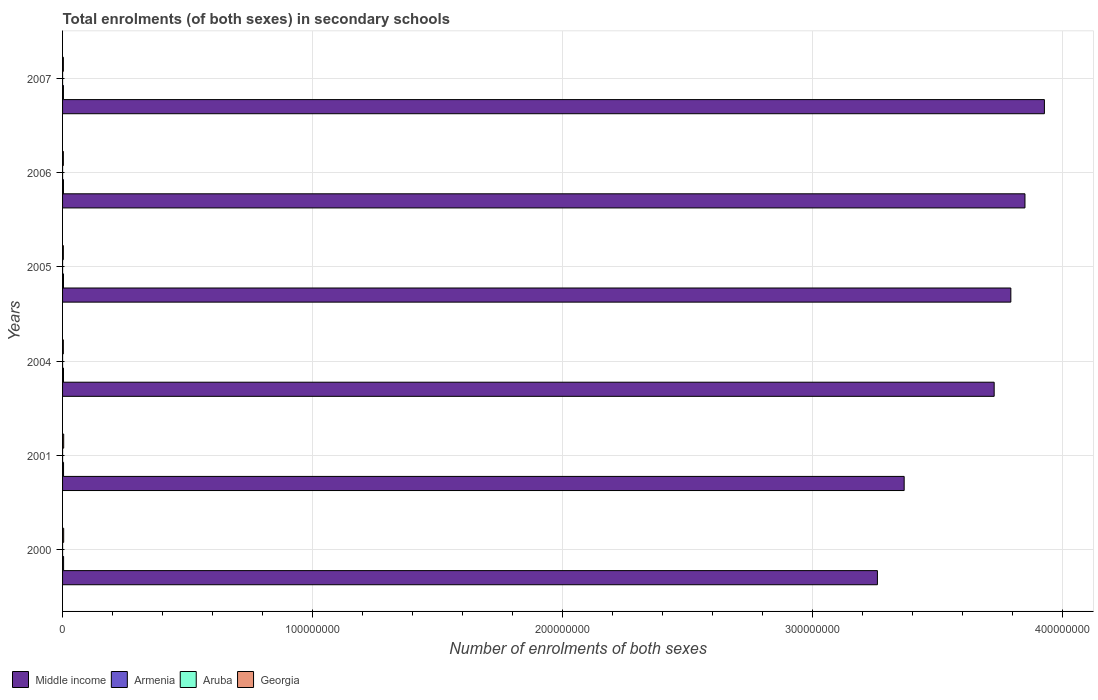Are the number of bars per tick equal to the number of legend labels?
Make the answer very short. Yes. Are the number of bars on each tick of the Y-axis equal?
Keep it short and to the point. Yes. How many bars are there on the 6th tick from the top?
Your answer should be compact. 4. In how many cases, is the number of bars for a given year not equal to the number of legend labels?
Your answer should be compact. 0. What is the number of enrolments in secondary schools in Middle income in 2005?
Give a very brief answer. 3.79e+08. Across all years, what is the maximum number of enrolments in secondary schools in Georgia?
Your answer should be very brief. 4.49e+05. Across all years, what is the minimum number of enrolments in secondary schools in Georgia?
Your answer should be compact. 3.12e+05. What is the total number of enrolments in secondary schools in Aruba in the graph?
Keep it short and to the point. 4.20e+04. What is the difference between the number of enrolments in secondary schools in Georgia in 2006 and that in 2007?
Give a very brief answer. -6744. What is the difference between the number of enrolments in secondary schools in Armenia in 2000 and the number of enrolments in secondary schools in Middle income in 2007?
Make the answer very short. -3.92e+08. What is the average number of enrolments in secondary schools in Aruba per year?
Keep it short and to the point. 6997.83. In the year 2000, what is the difference between the number of enrolments in secondary schools in Armenia and number of enrolments in secondary schools in Georgia?
Keep it short and to the point. -3.42e+04. What is the ratio of the number of enrolments in secondary schools in Armenia in 2000 to that in 2005?
Your answer should be very brief. 1.11. What is the difference between the highest and the second highest number of enrolments in secondary schools in Armenia?
Make the answer very short. 1.60e+04. What is the difference between the highest and the lowest number of enrolments in secondary schools in Armenia?
Offer a very short reply. 6.36e+04. Is it the case that in every year, the sum of the number of enrolments in secondary schools in Middle income and number of enrolments in secondary schools in Aruba is greater than the sum of number of enrolments in secondary schools in Armenia and number of enrolments in secondary schools in Georgia?
Offer a very short reply. Yes. What does the 3rd bar from the top in 2005 represents?
Provide a short and direct response. Armenia. What does the 1st bar from the bottom in 2004 represents?
Your answer should be very brief. Middle income. Is it the case that in every year, the sum of the number of enrolments in secondary schools in Armenia and number of enrolments in secondary schools in Georgia is greater than the number of enrolments in secondary schools in Aruba?
Provide a succinct answer. Yes. Are the values on the major ticks of X-axis written in scientific E-notation?
Offer a terse response. No. Does the graph contain grids?
Your response must be concise. Yes. Where does the legend appear in the graph?
Offer a terse response. Bottom left. How are the legend labels stacked?
Ensure brevity in your answer.  Horizontal. What is the title of the graph?
Keep it short and to the point. Total enrolments (of both sexes) in secondary schools. What is the label or title of the X-axis?
Give a very brief answer. Number of enrolments of both sexes. What is the Number of enrolments of both sexes of Middle income in 2000?
Ensure brevity in your answer.  3.26e+08. What is the Number of enrolments of both sexes in Armenia in 2000?
Offer a terse response. 4.09e+05. What is the Number of enrolments of both sexes of Aruba in 2000?
Offer a very short reply. 6178. What is the Number of enrolments of both sexes in Georgia in 2000?
Make the answer very short. 4.44e+05. What is the Number of enrolments of both sexes of Middle income in 2001?
Your answer should be very brief. 3.37e+08. What is the Number of enrolments of both sexes in Armenia in 2001?
Offer a terse response. 3.93e+05. What is the Number of enrolments of both sexes in Aruba in 2001?
Your answer should be very brief. 6428. What is the Number of enrolments of both sexes of Georgia in 2001?
Offer a very short reply. 4.49e+05. What is the Number of enrolments of both sexes of Middle income in 2004?
Ensure brevity in your answer.  3.73e+08. What is the Number of enrolments of both sexes in Armenia in 2004?
Your response must be concise. 3.74e+05. What is the Number of enrolments of both sexes of Aruba in 2004?
Keep it short and to the point. 6973. What is the Number of enrolments of both sexes in Georgia in 2004?
Give a very brief answer. 3.12e+05. What is the Number of enrolments of both sexes of Middle income in 2005?
Give a very brief answer. 3.79e+08. What is the Number of enrolments of both sexes of Armenia in 2005?
Give a very brief answer. 3.70e+05. What is the Number of enrolments of both sexes in Aruba in 2005?
Your response must be concise. 7116. What is the Number of enrolments of both sexes of Georgia in 2005?
Ensure brevity in your answer.  3.16e+05. What is the Number of enrolments of both sexes in Middle income in 2006?
Make the answer very short. 3.85e+08. What is the Number of enrolments of both sexes in Armenia in 2006?
Provide a succinct answer. 3.63e+05. What is the Number of enrolments of both sexes in Aruba in 2006?
Keep it short and to the point. 7439. What is the Number of enrolments of both sexes in Georgia in 2006?
Provide a succinct answer. 3.14e+05. What is the Number of enrolments of both sexes in Middle income in 2007?
Give a very brief answer. 3.93e+08. What is the Number of enrolments of both sexes of Armenia in 2007?
Ensure brevity in your answer.  3.46e+05. What is the Number of enrolments of both sexes of Aruba in 2007?
Give a very brief answer. 7853. What is the Number of enrolments of both sexes in Georgia in 2007?
Your answer should be very brief. 3.21e+05. Across all years, what is the maximum Number of enrolments of both sexes in Middle income?
Provide a short and direct response. 3.93e+08. Across all years, what is the maximum Number of enrolments of both sexes of Armenia?
Offer a terse response. 4.09e+05. Across all years, what is the maximum Number of enrolments of both sexes in Aruba?
Make the answer very short. 7853. Across all years, what is the maximum Number of enrolments of both sexes of Georgia?
Give a very brief answer. 4.49e+05. Across all years, what is the minimum Number of enrolments of both sexes of Middle income?
Provide a succinct answer. 3.26e+08. Across all years, what is the minimum Number of enrolments of both sexes in Armenia?
Give a very brief answer. 3.46e+05. Across all years, what is the minimum Number of enrolments of both sexes in Aruba?
Offer a terse response. 6178. Across all years, what is the minimum Number of enrolments of both sexes in Georgia?
Give a very brief answer. 3.12e+05. What is the total Number of enrolments of both sexes of Middle income in the graph?
Your answer should be very brief. 2.19e+09. What is the total Number of enrolments of both sexes in Armenia in the graph?
Make the answer very short. 2.25e+06. What is the total Number of enrolments of both sexes in Aruba in the graph?
Provide a succinct answer. 4.20e+04. What is the total Number of enrolments of both sexes in Georgia in the graph?
Keep it short and to the point. 2.16e+06. What is the difference between the Number of enrolments of both sexes of Middle income in 2000 and that in 2001?
Keep it short and to the point. -1.07e+07. What is the difference between the Number of enrolments of both sexes of Armenia in 2000 and that in 2001?
Give a very brief answer. 1.60e+04. What is the difference between the Number of enrolments of both sexes of Aruba in 2000 and that in 2001?
Make the answer very short. -250. What is the difference between the Number of enrolments of both sexes in Georgia in 2000 and that in 2001?
Make the answer very short. -4921. What is the difference between the Number of enrolments of both sexes in Middle income in 2000 and that in 2004?
Your answer should be very brief. -4.67e+07. What is the difference between the Number of enrolments of both sexes of Armenia in 2000 and that in 2004?
Provide a short and direct response. 3.57e+04. What is the difference between the Number of enrolments of both sexes of Aruba in 2000 and that in 2004?
Your response must be concise. -795. What is the difference between the Number of enrolments of both sexes in Georgia in 2000 and that in 2004?
Give a very brief answer. 1.31e+05. What is the difference between the Number of enrolments of both sexes of Middle income in 2000 and that in 2005?
Your answer should be very brief. -5.34e+07. What is the difference between the Number of enrolments of both sexes in Armenia in 2000 and that in 2005?
Your answer should be very brief. 3.97e+04. What is the difference between the Number of enrolments of both sexes in Aruba in 2000 and that in 2005?
Make the answer very short. -938. What is the difference between the Number of enrolments of both sexes of Georgia in 2000 and that in 2005?
Your answer should be very brief. 1.27e+05. What is the difference between the Number of enrolments of both sexes in Middle income in 2000 and that in 2006?
Offer a terse response. -5.90e+07. What is the difference between the Number of enrolments of both sexes of Armenia in 2000 and that in 2006?
Keep it short and to the point. 4.69e+04. What is the difference between the Number of enrolments of both sexes of Aruba in 2000 and that in 2006?
Provide a short and direct response. -1261. What is the difference between the Number of enrolments of both sexes in Georgia in 2000 and that in 2006?
Your response must be concise. 1.29e+05. What is the difference between the Number of enrolments of both sexes of Middle income in 2000 and that in 2007?
Give a very brief answer. -6.68e+07. What is the difference between the Number of enrolments of both sexes in Armenia in 2000 and that in 2007?
Ensure brevity in your answer.  6.36e+04. What is the difference between the Number of enrolments of both sexes of Aruba in 2000 and that in 2007?
Make the answer very short. -1675. What is the difference between the Number of enrolments of both sexes of Georgia in 2000 and that in 2007?
Your answer should be compact. 1.22e+05. What is the difference between the Number of enrolments of both sexes in Middle income in 2001 and that in 2004?
Offer a terse response. -3.60e+07. What is the difference between the Number of enrolments of both sexes in Armenia in 2001 and that in 2004?
Make the answer very short. 1.97e+04. What is the difference between the Number of enrolments of both sexes of Aruba in 2001 and that in 2004?
Offer a very short reply. -545. What is the difference between the Number of enrolments of both sexes in Georgia in 2001 and that in 2004?
Offer a very short reply. 1.36e+05. What is the difference between the Number of enrolments of both sexes of Middle income in 2001 and that in 2005?
Offer a very short reply. -4.27e+07. What is the difference between the Number of enrolments of both sexes of Armenia in 2001 and that in 2005?
Offer a terse response. 2.37e+04. What is the difference between the Number of enrolments of both sexes in Aruba in 2001 and that in 2005?
Give a very brief answer. -688. What is the difference between the Number of enrolments of both sexes in Georgia in 2001 and that in 2005?
Ensure brevity in your answer.  1.32e+05. What is the difference between the Number of enrolments of both sexes in Middle income in 2001 and that in 2006?
Provide a short and direct response. -4.83e+07. What is the difference between the Number of enrolments of both sexes in Armenia in 2001 and that in 2006?
Provide a succinct answer. 3.09e+04. What is the difference between the Number of enrolments of both sexes of Aruba in 2001 and that in 2006?
Offer a terse response. -1011. What is the difference between the Number of enrolments of both sexes in Georgia in 2001 and that in 2006?
Keep it short and to the point. 1.34e+05. What is the difference between the Number of enrolments of both sexes in Middle income in 2001 and that in 2007?
Your answer should be very brief. -5.61e+07. What is the difference between the Number of enrolments of both sexes in Armenia in 2001 and that in 2007?
Ensure brevity in your answer.  4.76e+04. What is the difference between the Number of enrolments of both sexes in Aruba in 2001 and that in 2007?
Make the answer very short. -1425. What is the difference between the Number of enrolments of both sexes in Georgia in 2001 and that in 2007?
Offer a terse response. 1.27e+05. What is the difference between the Number of enrolments of both sexes in Middle income in 2004 and that in 2005?
Your response must be concise. -6.67e+06. What is the difference between the Number of enrolments of both sexes of Armenia in 2004 and that in 2005?
Your answer should be very brief. 3957. What is the difference between the Number of enrolments of both sexes in Aruba in 2004 and that in 2005?
Give a very brief answer. -143. What is the difference between the Number of enrolments of both sexes of Georgia in 2004 and that in 2005?
Give a very brief answer. -4097. What is the difference between the Number of enrolments of both sexes of Middle income in 2004 and that in 2006?
Your response must be concise. -1.23e+07. What is the difference between the Number of enrolments of both sexes of Armenia in 2004 and that in 2006?
Your answer should be very brief. 1.12e+04. What is the difference between the Number of enrolments of both sexes of Aruba in 2004 and that in 2006?
Provide a succinct answer. -466. What is the difference between the Number of enrolments of both sexes of Georgia in 2004 and that in 2006?
Offer a terse response. -2094. What is the difference between the Number of enrolments of both sexes in Middle income in 2004 and that in 2007?
Provide a succinct answer. -2.01e+07. What is the difference between the Number of enrolments of both sexes in Armenia in 2004 and that in 2007?
Provide a succinct answer. 2.79e+04. What is the difference between the Number of enrolments of both sexes in Aruba in 2004 and that in 2007?
Your answer should be compact. -880. What is the difference between the Number of enrolments of both sexes in Georgia in 2004 and that in 2007?
Provide a short and direct response. -8838. What is the difference between the Number of enrolments of both sexes of Middle income in 2005 and that in 2006?
Provide a short and direct response. -5.65e+06. What is the difference between the Number of enrolments of both sexes in Armenia in 2005 and that in 2006?
Make the answer very short. 7194. What is the difference between the Number of enrolments of both sexes of Aruba in 2005 and that in 2006?
Keep it short and to the point. -323. What is the difference between the Number of enrolments of both sexes in Georgia in 2005 and that in 2006?
Your answer should be compact. 2003. What is the difference between the Number of enrolments of both sexes in Middle income in 2005 and that in 2007?
Your answer should be very brief. -1.34e+07. What is the difference between the Number of enrolments of both sexes in Armenia in 2005 and that in 2007?
Keep it short and to the point. 2.39e+04. What is the difference between the Number of enrolments of both sexes of Aruba in 2005 and that in 2007?
Make the answer very short. -737. What is the difference between the Number of enrolments of both sexes in Georgia in 2005 and that in 2007?
Keep it short and to the point. -4741. What is the difference between the Number of enrolments of both sexes in Middle income in 2006 and that in 2007?
Offer a terse response. -7.78e+06. What is the difference between the Number of enrolments of both sexes in Armenia in 2006 and that in 2007?
Your answer should be compact. 1.67e+04. What is the difference between the Number of enrolments of both sexes in Aruba in 2006 and that in 2007?
Ensure brevity in your answer.  -414. What is the difference between the Number of enrolments of both sexes in Georgia in 2006 and that in 2007?
Your answer should be compact. -6744. What is the difference between the Number of enrolments of both sexes in Middle income in 2000 and the Number of enrolments of both sexes in Armenia in 2001?
Offer a very short reply. 3.26e+08. What is the difference between the Number of enrolments of both sexes of Middle income in 2000 and the Number of enrolments of both sexes of Aruba in 2001?
Keep it short and to the point. 3.26e+08. What is the difference between the Number of enrolments of both sexes of Middle income in 2000 and the Number of enrolments of both sexes of Georgia in 2001?
Your answer should be compact. 3.25e+08. What is the difference between the Number of enrolments of both sexes in Armenia in 2000 and the Number of enrolments of both sexes in Aruba in 2001?
Offer a terse response. 4.03e+05. What is the difference between the Number of enrolments of both sexes of Armenia in 2000 and the Number of enrolments of both sexes of Georgia in 2001?
Your answer should be compact. -3.91e+04. What is the difference between the Number of enrolments of both sexes of Aruba in 2000 and the Number of enrolments of both sexes of Georgia in 2001?
Make the answer very short. -4.42e+05. What is the difference between the Number of enrolments of both sexes in Middle income in 2000 and the Number of enrolments of both sexes in Armenia in 2004?
Ensure brevity in your answer.  3.26e+08. What is the difference between the Number of enrolments of both sexes in Middle income in 2000 and the Number of enrolments of both sexes in Aruba in 2004?
Provide a short and direct response. 3.26e+08. What is the difference between the Number of enrolments of both sexes in Middle income in 2000 and the Number of enrolments of both sexes in Georgia in 2004?
Your answer should be very brief. 3.26e+08. What is the difference between the Number of enrolments of both sexes in Armenia in 2000 and the Number of enrolments of both sexes in Aruba in 2004?
Your answer should be compact. 4.02e+05. What is the difference between the Number of enrolments of both sexes of Armenia in 2000 and the Number of enrolments of both sexes of Georgia in 2004?
Ensure brevity in your answer.  9.71e+04. What is the difference between the Number of enrolments of both sexes of Aruba in 2000 and the Number of enrolments of both sexes of Georgia in 2004?
Make the answer very short. -3.06e+05. What is the difference between the Number of enrolments of both sexes of Middle income in 2000 and the Number of enrolments of both sexes of Armenia in 2005?
Ensure brevity in your answer.  3.26e+08. What is the difference between the Number of enrolments of both sexes of Middle income in 2000 and the Number of enrolments of both sexes of Aruba in 2005?
Offer a terse response. 3.26e+08. What is the difference between the Number of enrolments of both sexes of Middle income in 2000 and the Number of enrolments of both sexes of Georgia in 2005?
Offer a very short reply. 3.26e+08. What is the difference between the Number of enrolments of both sexes in Armenia in 2000 and the Number of enrolments of both sexes in Aruba in 2005?
Provide a succinct answer. 4.02e+05. What is the difference between the Number of enrolments of both sexes of Armenia in 2000 and the Number of enrolments of both sexes of Georgia in 2005?
Your answer should be compact. 9.30e+04. What is the difference between the Number of enrolments of both sexes of Aruba in 2000 and the Number of enrolments of both sexes of Georgia in 2005?
Give a very brief answer. -3.10e+05. What is the difference between the Number of enrolments of both sexes of Middle income in 2000 and the Number of enrolments of both sexes of Armenia in 2006?
Offer a terse response. 3.26e+08. What is the difference between the Number of enrolments of both sexes in Middle income in 2000 and the Number of enrolments of both sexes in Aruba in 2006?
Offer a very short reply. 3.26e+08. What is the difference between the Number of enrolments of both sexes of Middle income in 2000 and the Number of enrolments of both sexes of Georgia in 2006?
Provide a succinct answer. 3.26e+08. What is the difference between the Number of enrolments of both sexes of Armenia in 2000 and the Number of enrolments of both sexes of Aruba in 2006?
Keep it short and to the point. 4.02e+05. What is the difference between the Number of enrolments of both sexes in Armenia in 2000 and the Number of enrolments of both sexes in Georgia in 2006?
Make the answer very short. 9.50e+04. What is the difference between the Number of enrolments of both sexes of Aruba in 2000 and the Number of enrolments of both sexes of Georgia in 2006?
Provide a short and direct response. -3.08e+05. What is the difference between the Number of enrolments of both sexes in Middle income in 2000 and the Number of enrolments of both sexes in Armenia in 2007?
Give a very brief answer. 3.26e+08. What is the difference between the Number of enrolments of both sexes of Middle income in 2000 and the Number of enrolments of both sexes of Aruba in 2007?
Provide a succinct answer. 3.26e+08. What is the difference between the Number of enrolments of both sexes of Middle income in 2000 and the Number of enrolments of both sexes of Georgia in 2007?
Offer a very short reply. 3.26e+08. What is the difference between the Number of enrolments of both sexes in Armenia in 2000 and the Number of enrolments of both sexes in Aruba in 2007?
Ensure brevity in your answer.  4.02e+05. What is the difference between the Number of enrolments of both sexes in Armenia in 2000 and the Number of enrolments of both sexes in Georgia in 2007?
Give a very brief answer. 8.83e+04. What is the difference between the Number of enrolments of both sexes in Aruba in 2000 and the Number of enrolments of both sexes in Georgia in 2007?
Your answer should be very brief. -3.15e+05. What is the difference between the Number of enrolments of both sexes of Middle income in 2001 and the Number of enrolments of both sexes of Armenia in 2004?
Your response must be concise. 3.36e+08. What is the difference between the Number of enrolments of both sexes in Middle income in 2001 and the Number of enrolments of both sexes in Aruba in 2004?
Your response must be concise. 3.37e+08. What is the difference between the Number of enrolments of both sexes in Middle income in 2001 and the Number of enrolments of both sexes in Georgia in 2004?
Provide a succinct answer. 3.36e+08. What is the difference between the Number of enrolments of both sexes of Armenia in 2001 and the Number of enrolments of both sexes of Aruba in 2004?
Your answer should be very brief. 3.86e+05. What is the difference between the Number of enrolments of both sexes of Armenia in 2001 and the Number of enrolments of both sexes of Georgia in 2004?
Provide a succinct answer. 8.11e+04. What is the difference between the Number of enrolments of both sexes in Aruba in 2001 and the Number of enrolments of both sexes in Georgia in 2004?
Make the answer very short. -3.06e+05. What is the difference between the Number of enrolments of both sexes of Middle income in 2001 and the Number of enrolments of both sexes of Armenia in 2005?
Make the answer very short. 3.36e+08. What is the difference between the Number of enrolments of both sexes of Middle income in 2001 and the Number of enrolments of both sexes of Aruba in 2005?
Your answer should be compact. 3.37e+08. What is the difference between the Number of enrolments of both sexes of Middle income in 2001 and the Number of enrolments of both sexes of Georgia in 2005?
Make the answer very short. 3.36e+08. What is the difference between the Number of enrolments of both sexes in Armenia in 2001 and the Number of enrolments of both sexes in Aruba in 2005?
Ensure brevity in your answer.  3.86e+05. What is the difference between the Number of enrolments of both sexes of Armenia in 2001 and the Number of enrolments of both sexes of Georgia in 2005?
Your response must be concise. 7.70e+04. What is the difference between the Number of enrolments of both sexes of Aruba in 2001 and the Number of enrolments of both sexes of Georgia in 2005?
Provide a succinct answer. -3.10e+05. What is the difference between the Number of enrolments of both sexes in Middle income in 2001 and the Number of enrolments of both sexes in Armenia in 2006?
Your answer should be compact. 3.36e+08. What is the difference between the Number of enrolments of both sexes in Middle income in 2001 and the Number of enrolments of both sexes in Aruba in 2006?
Your answer should be very brief. 3.37e+08. What is the difference between the Number of enrolments of both sexes in Middle income in 2001 and the Number of enrolments of both sexes in Georgia in 2006?
Offer a terse response. 3.36e+08. What is the difference between the Number of enrolments of both sexes of Armenia in 2001 and the Number of enrolments of both sexes of Aruba in 2006?
Your response must be concise. 3.86e+05. What is the difference between the Number of enrolments of both sexes in Armenia in 2001 and the Number of enrolments of both sexes in Georgia in 2006?
Offer a very short reply. 7.90e+04. What is the difference between the Number of enrolments of both sexes in Aruba in 2001 and the Number of enrolments of both sexes in Georgia in 2006?
Your response must be concise. -3.08e+05. What is the difference between the Number of enrolments of both sexes in Middle income in 2001 and the Number of enrolments of both sexes in Armenia in 2007?
Keep it short and to the point. 3.36e+08. What is the difference between the Number of enrolments of both sexes in Middle income in 2001 and the Number of enrolments of both sexes in Aruba in 2007?
Offer a very short reply. 3.37e+08. What is the difference between the Number of enrolments of both sexes of Middle income in 2001 and the Number of enrolments of both sexes of Georgia in 2007?
Your answer should be compact. 3.36e+08. What is the difference between the Number of enrolments of both sexes in Armenia in 2001 and the Number of enrolments of both sexes in Aruba in 2007?
Your response must be concise. 3.86e+05. What is the difference between the Number of enrolments of both sexes in Armenia in 2001 and the Number of enrolments of both sexes in Georgia in 2007?
Provide a succinct answer. 7.22e+04. What is the difference between the Number of enrolments of both sexes of Aruba in 2001 and the Number of enrolments of both sexes of Georgia in 2007?
Your answer should be very brief. -3.15e+05. What is the difference between the Number of enrolments of both sexes in Middle income in 2004 and the Number of enrolments of both sexes in Armenia in 2005?
Your answer should be very brief. 3.72e+08. What is the difference between the Number of enrolments of both sexes of Middle income in 2004 and the Number of enrolments of both sexes of Aruba in 2005?
Provide a short and direct response. 3.73e+08. What is the difference between the Number of enrolments of both sexes of Middle income in 2004 and the Number of enrolments of both sexes of Georgia in 2005?
Your answer should be compact. 3.72e+08. What is the difference between the Number of enrolments of both sexes of Armenia in 2004 and the Number of enrolments of both sexes of Aruba in 2005?
Provide a succinct answer. 3.67e+05. What is the difference between the Number of enrolments of both sexes in Armenia in 2004 and the Number of enrolments of both sexes in Georgia in 2005?
Your response must be concise. 5.73e+04. What is the difference between the Number of enrolments of both sexes in Aruba in 2004 and the Number of enrolments of both sexes in Georgia in 2005?
Provide a short and direct response. -3.09e+05. What is the difference between the Number of enrolments of both sexes in Middle income in 2004 and the Number of enrolments of both sexes in Armenia in 2006?
Your answer should be compact. 3.72e+08. What is the difference between the Number of enrolments of both sexes of Middle income in 2004 and the Number of enrolments of both sexes of Aruba in 2006?
Your answer should be very brief. 3.73e+08. What is the difference between the Number of enrolments of both sexes in Middle income in 2004 and the Number of enrolments of both sexes in Georgia in 2006?
Provide a succinct answer. 3.72e+08. What is the difference between the Number of enrolments of both sexes of Armenia in 2004 and the Number of enrolments of both sexes of Aruba in 2006?
Ensure brevity in your answer.  3.66e+05. What is the difference between the Number of enrolments of both sexes in Armenia in 2004 and the Number of enrolments of both sexes in Georgia in 2006?
Provide a short and direct response. 5.93e+04. What is the difference between the Number of enrolments of both sexes of Aruba in 2004 and the Number of enrolments of both sexes of Georgia in 2006?
Offer a very short reply. -3.07e+05. What is the difference between the Number of enrolments of both sexes of Middle income in 2004 and the Number of enrolments of both sexes of Armenia in 2007?
Offer a very short reply. 3.72e+08. What is the difference between the Number of enrolments of both sexes of Middle income in 2004 and the Number of enrolments of both sexes of Aruba in 2007?
Keep it short and to the point. 3.73e+08. What is the difference between the Number of enrolments of both sexes of Middle income in 2004 and the Number of enrolments of both sexes of Georgia in 2007?
Make the answer very short. 3.72e+08. What is the difference between the Number of enrolments of both sexes of Armenia in 2004 and the Number of enrolments of both sexes of Aruba in 2007?
Ensure brevity in your answer.  3.66e+05. What is the difference between the Number of enrolments of both sexes in Armenia in 2004 and the Number of enrolments of both sexes in Georgia in 2007?
Provide a short and direct response. 5.25e+04. What is the difference between the Number of enrolments of both sexes of Aruba in 2004 and the Number of enrolments of both sexes of Georgia in 2007?
Ensure brevity in your answer.  -3.14e+05. What is the difference between the Number of enrolments of both sexes of Middle income in 2005 and the Number of enrolments of both sexes of Armenia in 2006?
Make the answer very short. 3.79e+08. What is the difference between the Number of enrolments of both sexes in Middle income in 2005 and the Number of enrolments of both sexes in Aruba in 2006?
Your answer should be compact. 3.79e+08. What is the difference between the Number of enrolments of both sexes of Middle income in 2005 and the Number of enrolments of both sexes of Georgia in 2006?
Your answer should be very brief. 3.79e+08. What is the difference between the Number of enrolments of both sexes in Armenia in 2005 and the Number of enrolments of both sexes in Aruba in 2006?
Give a very brief answer. 3.62e+05. What is the difference between the Number of enrolments of both sexes in Armenia in 2005 and the Number of enrolments of both sexes in Georgia in 2006?
Offer a very short reply. 5.53e+04. What is the difference between the Number of enrolments of both sexes in Aruba in 2005 and the Number of enrolments of both sexes in Georgia in 2006?
Your response must be concise. -3.07e+05. What is the difference between the Number of enrolments of both sexes in Middle income in 2005 and the Number of enrolments of both sexes in Armenia in 2007?
Give a very brief answer. 3.79e+08. What is the difference between the Number of enrolments of both sexes of Middle income in 2005 and the Number of enrolments of both sexes of Aruba in 2007?
Your response must be concise. 3.79e+08. What is the difference between the Number of enrolments of both sexes of Middle income in 2005 and the Number of enrolments of both sexes of Georgia in 2007?
Offer a terse response. 3.79e+08. What is the difference between the Number of enrolments of both sexes in Armenia in 2005 and the Number of enrolments of both sexes in Aruba in 2007?
Your answer should be very brief. 3.62e+05. What is the difference between the Number of enrolments of both sexes in Armenia in 2005 and the Number of enrolments of both sexes in Georgia in 2007?
Offer a very short reply. 4.86e+04. What is the difference between the Number of enrolments of both sexes in Aruba in 2005 and the Number of enrolments of both sexes in Georgia in 2007?
Your answer should be very brief. -3.14e+05. What is the difference between the Number of enrolments of both sexes in Middle income in 2006 and the Number of enrolments of both sexes in Armenia in 2007?
Your answer should be very brief. 3.85e+08. What is the difference between the Number of enrolments of both sexes in Middle income in 2006 and the Number of enrolments of both sexes in Aruba in 2007?
Offer a terse response. 3.85e+08. What is the difference between the Number of enrolments of both sexes in Middle income in 2006 and the Number of enrolments of both sexes in Georgia in 2007?
Make the answer very short. 3.85e+08. What is the difference between the Number of enrolments of both sexes of Armenia in 2006 and the Number of enrolments of both sexes of Aruba in 2007?
Keep it short and to the point. 3.55e+05. What is the difference between the Number of enrolments of both sexes of Armenia in 2006 and the Number of enrolments of both sexes of Georgia in 2007?
Your response must be concise. 4.14e+04. What is the difference between the Number of enrolments of both sexes of Aruba in 2006 and the Number of enrolments of both sexes of Georgia in 2007?
Provide a succinct answer. -3.14e+05. What is the average Number of enrolments of both sexes in Middle income per year?
Your response must be concise. 3.65e+08. What is the average Number of enrolments of both sexes in Armenia per year?
Your response must be concise. 3.76e+05. What is the average Number of enrolments of both sexes of Aruba per year?
Provide a short and direct response. 6997.83. What is the average Number of enrolments of both sexes of Georgia per year?
Make the answer very short. 3.59e+05. In the year 2000, what is the difference between the Number of enrolments of both sexes of Middle income and Number of enrolments of both sexes of Armenia?
Offer a terse response. 3.26e+08. In the year 2000, what is the difference between the Number of enrolments of both sexes of Middle income and Number of enrolments of both sexes of Aruba?
Provide a short and direct response. 3.26e+08. In the year 2000, what is the difference between the Number of enrolments of both sexes of Middle income and Number of enrolments of both sexes of Georgia?
Keep it short and to the point. 3.26e+08. In the year 2000, what is the difference between the Number of enrolments of both sexes of Armenia and Number of enrolments of both sexes of Aruba?
Offer a terse response. 4.03e+05. In the year 2000, what is the difference between the Number of enrolments of both sexes of Armenia and Number of enrolments of both sexes of Georgia?
Keep it short and to the point. -3.42e+04. In the year 2000, what is the difference between the Number of enrolments of both sexes of Aruba and Number of enrolments of both sexes of Georgia?
Offer a very short reply. -4.37e+05. In the year 2001, what is the difference between the Number of enrolments of both sexes in Middle income and Number of enrolments of both sexes in Armenia?
Offer a very short reply. 3.36e+08. In the year 2001, what is the difference between the Number of enrolments of both sexes in Middle income and Number of enrolments of both sexes in Aruba?
Give a very brief answer. 3.37e+08. In the year 2001, what is the difference between the Number of enrolments of both sexes in Middle income and Number of enrolments of both sexes in Georgia?
Keep it short and to the point. 3.36e+08. In the year 2001, what is the difference between the Number of enrolments of both sexes in Armenia and Number of enrolments of both sexes in Aruba?
Give a very brief answer. 3.87e+05. In the year 2001, what is the difference between the Number of enrolments of both sexes of Armenia and Number of enrolments of both sexes of Georgia?
Make the answer very short. -5.51e+04. In the year 2001, what is the difference between the Number of enrolments of both sexes in Aruba and Number of enrolments of both sexes in Georgia?
Make the answer very short. -4.42e+05. In the year 2004, what is the difference between the Number of enrolments of both sexes of Middle income and Number of enrolments of both sexes of Armenia?
Your answer should be compact. 3.72e+08. In the year 2004, what is the difference between the Number of enrolments of both sexes in Middle income and Number of enrolments of both sexes in Aruba?
Offer a very short reply. 3.73e+08. In the year 2004, what is the difference between the Number of enrolments of both sexes in Middle income and Number of enrolments of both sexes in Georgia?
Your response must be concise. 3.72e+08. In the year 2004, what is the difference between the Number of enrolments of both sexes of Armenia and Number of enrolments of both sexes of Aruba?
Your answer should be compact. 3.67e+05. In the year 2004, what is the difference between the Number of enrolments of both sexes in Armenia and Number of enrolments of both sexes in Georgia?
Offer a very short reply. 6.14e+04. In the year 2004, what is the difference between the Number of enrolments of both sexes in Aruba and Number of enrolments of both sexes in Georgia?
Ensure brevity in your answer.  -3.05e+05. In the year 2005, what is the difference between the Number of enrolments of both sexes in Middle income and Number of enrolments of both sexes in Armenia?
Keep it short and to the point. 3.79e+08. In the year 2005, what is the difference between the Number of enrolments of both sexes in Middle income and Number of enrolments of both sexes in Aruba?
Your answer should be very brief. 3.79e+08. In the year 2005, what is the difference between the Number of enrolments of both sexes of Middle income and Number of enrolments of both sexes of Georgia?
Your answer should be very brief. 3.79e+08. In the year 2005, what is the difference between the Number of enrolments of both sexes of Armenia and Number of enrolments of both sexes of Aruba?
Make the answer very short. 3.63e+05. In the year 2005, what is the difference between the Number of enrolments of both sexes of Armenia and Number of enrolments of both sexes of Georgia?
Ensure brevity in your answer.  5.33e+04. In the year 2005, what is the difference between the Number of enrolments of both sexes of Aruba and Number of enrolments of both sexes of Georgia?
Offer a very short reply. -3.09e+05. In the year 2006, what is the difference between the Number of enrolments of both sexes of Middle income and Number of enrolments of both sexes of Armenia?
Offer a very short reply. 3.85e+08. In the year 2006, what is the difference between the Number of enrolments of both sexes of Middle income and Number of enrolments of both sexes of Aruba?
Ensure brevity in your answer.  3.85e+08. In the year 2006, what is the difference between the Number of enrolments of both sexes of Middle income and Number of enrolments of both sexes of Georgia?
Your answer should be compact. 3.85e+08. In the year 2006, what is the difference between the Number of enrolments of both sexes of Armenia and Number of enrolments of both sexes of Aruba?
Your answer should be very brief. 3.55e+05. In the year 2006, what is the difference between the Number of enrolments of both sexes of Armenia and Number of enrolments of both sexes of Georgia?
Keep it short and to the point. 4.81e+04. In the year 2006, what is the difference between the Number of enrolments of both sexes of Aruba and Number of enrolments of both sexes of Georgia?
Offer a terse response. -3.07e+05. In the year 2007, what is the difference between the Number of enrolments of both sexes of Middle income and Number of enrolments of both sexes of Armenia?
Make the answer very short. 3.92e+08. In the year 2007, what is the difference between the Number of enrolments of both sexes of Middle income and Number of enrolments of both sexes of Aruba?
Give a very brief answer. 3.93e+08. In the year 2007, what is the difference between the Number of enrolments of both sexes in Middle income and Number of enrolments of both sexes in Georgia?
Your response must be concise. 3.92e+08. In the year 2007, what is the difference between the Number of enrolments of both sexes of Armenia and Number of enrolments of both sexes of Aruba?
Your answer should be very brief. 3.38e+05. In the year 2007, what is the difference between the Number of enrolments of both sexes of Armenia and Number of enrolments of both sexes of Georgia?
Give a very brief answer. 2.47e+04. In the year 2007, what is the difference between the Number of enrolments of both sexes in Aruba and Number of enrolments of both sexes in Georgia?
Provide a short and direct response. -3.13e+05. What is the ratio of the Number of enrolments of both sexes of Middle income in 2000 to that in 2001?
Give a very brief answer. 0.97. What is the ratio of the Number of enrolments of both sexes in Armenia in 2000 to that in 2001?
Your answer should be very brief. 1.04. What is the ratio of the Number of enrolments of both sexes in Aruba in 2000 to that in 2001?
Your answer should be compact. 0.96. What is the ratio of the Number of enrolments of both sexes of Middle income in 2000 to that in 2004?
Provide a succinct answer. 0.87. What is the ratio of the Number of enrolments of both sexes of Armenia in 2000 to that in 2004?
Provide a short and direct response. 1.1. What is the ratio of the Number of enrolments of both sexes of Aruba in 2000 to that in 2004?
Your response must be concise. 0.89. What is the ratio of the Number of enrolments of both sexes of Georgia in 2000 to that in 2004?
Offer a terse response. 1.42. What is the ratio of the Number of enrolments of both sexes of Middle income in 2000 to that in 2005?
Your answer should be compact. 0.86. What is the ratio of the Number of enrolments of both sexes in Armenia in 2000 to that in 2005?
Offer a terse response. 1.11. What is the ratio of the Number of enrolments of both sexes in Aruba in 2000 to that in 2005?
Offer a very short reply. 0.87. What is the ratio of the Number of enrolments of both sexes in Georgia in 2000 to that in 2005?
Give a very brief answer. 1.4. What is the ratio of the Number of enrolments of both sexes of Middle income in 2000 to that in 2006?
Your response must be concise. 0.85. What is the ratio of the Number of enrolments of both sexes of Armenia in 2000 to that in 2006?
Your answer should be very brief. 1.13. What is the ratio of the Number of enrolments of both sexes of Aruba in 2000 to that in 2006?
Offer a terse response. 0.83. What is the ratio of the Number of enrolments of both sexes of Georgia in 2000 to that in 2006?
Offer a terse response. 1.41. What is the ratio of the Number of enrolments of both sexes of Middle income in 2000 to that in 2007?
Provide a succinct answer. 0.83. What is the ratio of the Number of enrolments of both sexes of Armenia in 2000 to that in 2007?
Offer a terse response. 1.18. What is the ratio of the Number of enrolments of both sexes of Aruba in 2000 to that in 2007?
Make the answer very short. 0.79. What is the ratio of the Number of enrolments of both sexes of Georgia in 2000 to that in 2007?
Offer a very short reply. 1.38. What is the ratio of the Number of enrolments of both sexes of Middle income in 2001 to that in 2004?
Ensure brevity in your answer.  0.9. What is the ratio of the Number of enrolments of both sexes in Armenia in 2001 to that in 2004?
Your answer should be very brief. 1.05. What is the ratio of the Number of enrolments of both sexes in Aruba in 2001 to that in 2004?
Make the answer very short. 0.92. What is the ratio of the Number of enrolments of both sexes in Georgia in 2001 to that in 2004?
Ensure brevity in your answer.  1.44. What is the ratio of the Number of enrolments of both sexes in Middle income in 2001 to that in 2005?
Keep it short and to the point. 0.89. What is the ratio of the Number of enrolments of both sexes of Armenia in 2001 to that in 2005?
Your answer should be compact. 1.06. What is the ratio of the Number of enrolments of both sexes in Aruba in 2001 to that in 2005?
Keep it short and to the point. 0.9. What is the ratio of the Number of enrolments of both sexes in Georgia in 2001 to that in 2005?
Make the answer very short. 1.42. What is the ratio of the Number of enrolments of both sexes in Middle income in 2001 to that in 2006?
Ensure brevity in your answer.  0.87. What is the ratio of the Number of enrolments of both sexes in Armenia in 2001 to that in 2006?
Provide a succinct answer. 1.09. What is the ratio of the Number of enrolments of both sexes in Aruba in 2001 to that in 2006?
Offer a terse response. 0.86. What is the ratio of the Number of enrolments of both sexes of Georgia in 2001 to that in 2006?
Ensure brevity in your answer.  1.43. What is the ratio of the Number of enrolments of both sexes in Middle income in 2001 to that in 2007?
Provide a short and direct response. 0.86. What is the ratio of the Number of enrolments of both sexes in Armenia in 2001 to that in 2007?
Your answer should be compact. 1.14. What is the ratio of the Number of enrolments of both sexes of Aruba in 2001 to that in 2007?
Provide a succinct answer. 0.82. What is the ratio of the Number of enrolments of both sexes in Georgia in 2001 to that in 2007?
Offer a terse response. 1.4. What is the ratio of the Number of enrolments of both sexes in Middle income in 2004 to that in 2005?
Offer a very short reply. 0.98. What is the ratio of the Number of enrolments of both sexes of Armenia in 2004 to that in 2005?
Offer a very short reply. 1.01. What is the ratio of the Number of enrolments of both sexes of Aruba in 2004 to that in 2005?
Ensure brevity in your answer.  0.98. What is the ratio of the Number of enrolments of both sexes of Georgia in 2004 to that in 2005?
Keep it short and to the point. 0.99. What is the ratio of the Number of enrolments of both sexes in Middle income in 2004 to that in 2006?
Give a very brief answer. 0.97. What is the ratio of the Number of enrolments of both sexes in Armenia in 2004 to that in 2006?
Ensure brevity in your answer.  1.03. What is the ratio of the Number of enrolments of both sexes of Aruba in 2004 to that in 2006?
Your answer should be compact. 0.94. What is the ratio of the Number of enrolments of both sexes of Georgia in 2004 to that in 2006?
Make the answer very short. 0.99. What is the ratio of the Number of enrolments of both sexes of Middle income in 2004 to that in 2007?
Provide a short and direct response. 0.95. What is the ratio of the Number of enrolments of both sexes of Armenia in 2004 to that in 2007?
Your answer should be compact. 1.08. What is the ratio of the Number of enrolments of both sexes of Aruba in 2004 to that in 2007?
Offer a terse response. 0.89. What is the ratio of the Number of enrolments of both sexes of Georgia in 2004 to that in 2007?
Offer a very short reply. 0.97. What is the ratio of the Number of enrolments of both sexes in Armenia in 2005 to that in 2006?
Provide a short and direct response. 1.02. What is the ratio of the Number of enrolments of both sexes of Aruba in 2005 to that in 2006?
Your answer should be very brief. 0.96. What is the ratio of the Number of enrolments of both sexes in Georgia in 2005 to that in 2006?
Offer a terse response. 1.01. What is the ratio of the Number of enrolments of both sexes in Middle income in 2005 to that in 2007?
Provide a succinct answer. 0.97. What is the ratio of the Number of enrolments of both sexes in Armenia in 2005 to that in 2007?
Your answer should be very brief. 1.07. What is the ratio of the Number of enrolments of both sexes in Aruba in 2005 to that in 2007?
Keep it short and to the point. 0.91. What is the ratio of the Number of enrolments of both sexes of Georgia in 2005 to that in 2007?
Make the answer very short. 0.99. What is the ratio of the Number of enrolments of both sexes in Middle income in 2006 to that in 2007?
Your answer should be compact. 0.98. What is the ratio of the Number of enrolments of both sexes in Armenia in 2006 to that in 2007?
Make the answer very short. 1.05. What is the ratio of the Number of enrolments of both sexes in Aruba in 2006 to that in 2007?
Give a very brief answer. 0.95. What is the difference between the highest and the second highest Number of enrolments of both sexes in Middle income?
Keep it short and to the point. 7.78e+06. What is the difference between the highest and the second highest Number of enrolments of both sexes of Armenia?
Provide a short and direct response. 1.60e+04. What is the difference between the highest and the second highest Number of enrolments of both sexes in Aruba?
Your response must be concise. 414. What is the difference between the highest and the second highest Number of enrolments of both sexes of Georgia?
Provide a short and direct response. 4921. What is the difference between the highest and the lowest Number of enrolments of both sexes of Middle income?
Provide a short and direct response. 6.68e+07. What is the difference between the highest and the lowest Number of enrolments of both sexes of Armenia?
Offer a very short reply. 6.36e+04. What is the difference between the highest and the lowest Number of enrolments of both sexes in Aruba?
Make the answer very short. 1675. What is the difference between the highest and the lowest Number of enrolments of both sexes in Georgia?
Provide a short and direct response. 1.36e+05. 